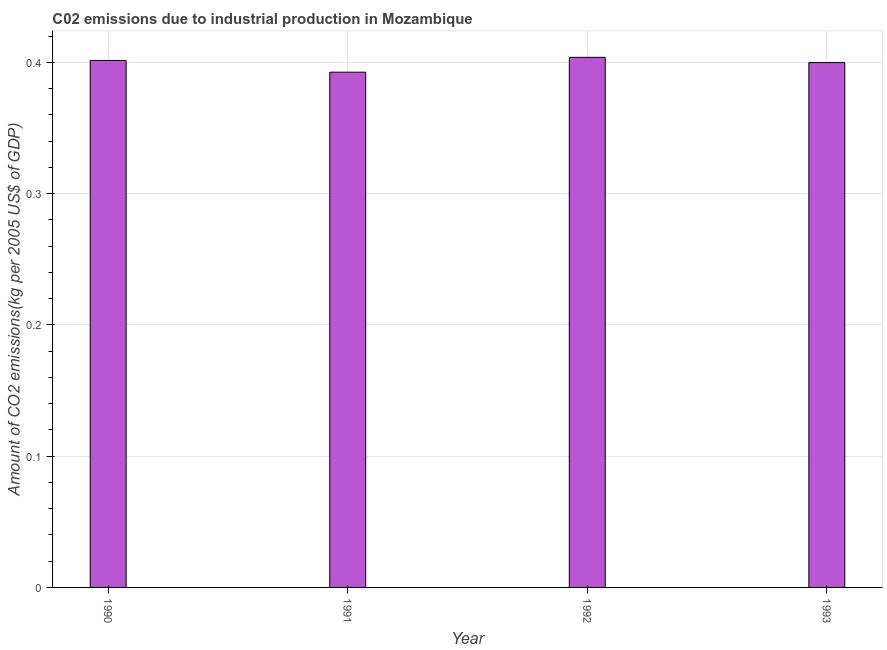Does the graph contain any zero values?
Give a very brief answer. No. Does the graph contain grids?
Your response must be concise. Yes. What is the title of the graph?
Offer a very short reply. C02 emissions due to industrial production in Mozambique. What is the label or title of the X-axis?
Make the answer very short. Year. What is the label or title of the Y-axis?
Keep it short and to the point. Amount of CO2 emissions(kg per 2005 US$ of GDP). What is the amount of co2 emissions in 1992?
Offer a terse response. 0.4. Across all years, what is the maximum amount of co2 emissions?
Your response must be concise. 0.4. Across all years, what is the minimum amount of co2 emissions?
Give a very brief answer. 0.39. In which year was the amount of co2 emissions maximum?
Provide a succinct answer. 1992. What is the sum of the amount of co2 emissions?
Keep it short and to the point. 1.6. What is the difference between the amount of co2 emissions in 1990 and 1991?
Your answer should be compact. 0.01. What is the average amount of co2 emissions per year?
Ensure brevity in your answer.  0.4. What is the median amount of co2 emissions?
Give a very brief answer. 0.4. What is the ratio of the amount of co2 emissions in 1991 to that in 1992?
Offer a very short reply. 0.97. Is the amount of co2 emissions in 1991 less than that in 1993?
Provide a short and direct response. Yes. What is the difference between the highest and the second highest amount of co2 emissions?
Ensure brevity in your answer.  0. What is the difference between the highest and the lowest amount of co2 emissions?
Offer a terse response. 0.01. Are all the bars in the graph horizontal?
Make the answer very short. No. What is the difference between two consecutive major ticks on the Y-axis?
Give a very brief answer. 0.1. What is the Amount of CO2 emissions(kg per 2005 US$ of GDP) of 1990?
Your response must be concise. 0.4. What is the Amount of CO2 emissions(kg per 2005 US$ of GDP) of 1991?
Make the answer very short. 0.39. What is the Amount of CO2 emissions(kg per 2005 US$ of GDP) of 1992?
Keep it short and to the point. 0.4. What is the Amount of CO2 emissions(kg per 2005 US$ of GDP) in 1993?
Provide a succinct answer. 0.4. What is the difference between the Amount of CO2 emissions(kg per 2005 US$ of GDP) in 1990 and 1991?
Your answer should be very brief. 0.01. What is the difference between the Amount of CO2 emissions(kg per 2005 US$ of GDP) in 1990 and 1992?
Your answer should be very brief. -0. What is the difference between the Amount of CO2 emissions(kg per 2005 US$ of GDP) in 1990 and 1993?
Your response must be concise. 0. What is the difference between the Amount of CO2 emissions(kg per 2005 US$ of GDP) in 1991 and 1992?
Provide a succinct answer. -0.01. What is the difference between the Amount of CO2 emissions(kg per 2005 US$ of GDP) in 1991 and 1993?
Give a very brief answer. -0.01. What is the difference between the Amount of CO2 emissions(kg per 2005 US$ of GDP) in 1992 and 1993?
Keep it short and to the point. 0. What is the ratio of the Amount of CO2 emissions(kg per 2005 US$ of GDP) in 1990 to that in 1991?
Your answer should be very brief. 1.02. What is the ratio of the Amount of CO2 emissions(kg per 2005 US$ of GDP) in 1991 to that in 1993?
Give a very brief answer. 0.98. 